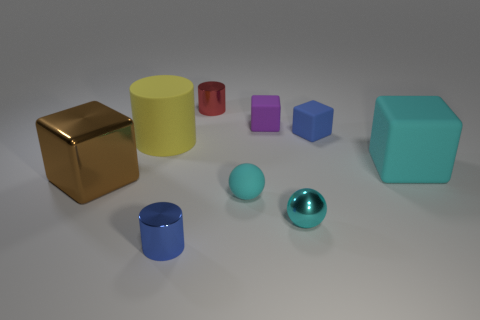What color is the big shiny block?
Offer a terse response. Brown. Is the number of small blue objects behind the purple cube greater than the number of spheres that are in front of the small blue cylinder?
Offer a terse response. No. There is a large thing on the right side of the big rubber cylinder; what color is it?
Your answer should be compact. Cyan. Do the metallic object that is to the left of the yellow cylinder and the blue thing behind the blue metallic cylinder have the same size?
Your response must be concise. No. What number of objects are large purple things or blue cylinders?
Provide a short and direct response. 1. What material is the tiny blue thing that is in front of the metal object to the left of the blue metallic object?
Offer a terse response. Metal. How many other brown metallic things are the same shape as the brown metallic object?
Your answer should be very brief. 0. Are there any tiny shiny cylinders of the same color as the big metal block?
Give a very brief answer. No. How many things are either tiny matte objects in front of the large brown thing or blue objects behind the small blue cylinder?
Give a very brief answer. 2. There is a metallic cylinder that is in front of the large yellow matte object; is there a red thing that is behind it?
Give a very brief answer. Yes. 